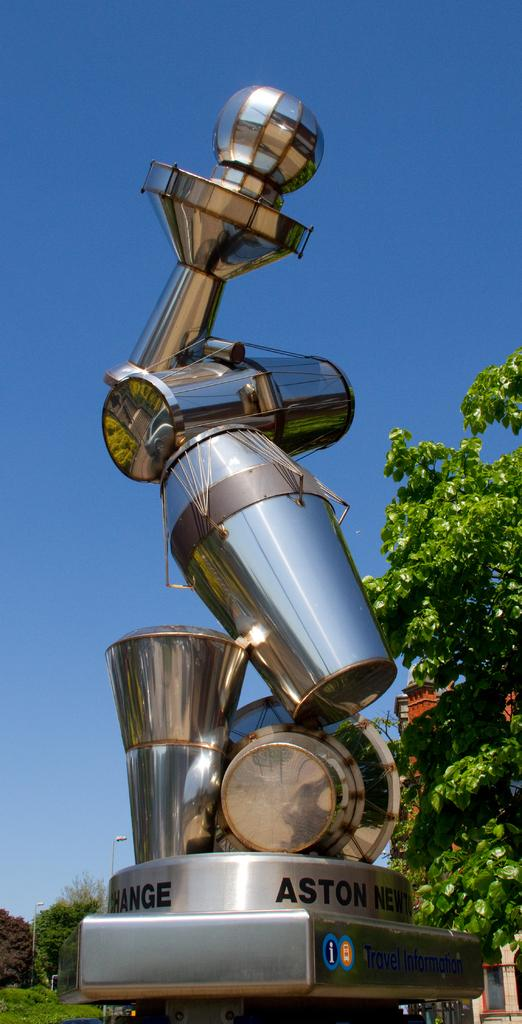What is the main subject in the middle of the image? There is a metal statue in the middle of the image. What is located behind the statue? There are trees behind the statue. How are the trees distributed in the image? The trees are located all over the place. What can be seen above the statue in the image? The sky is visible above the statue. What type of cherry is hanging from the branches of the trees in the image? There is no cherry present in the image; the trees are not specified as cherry trees. 